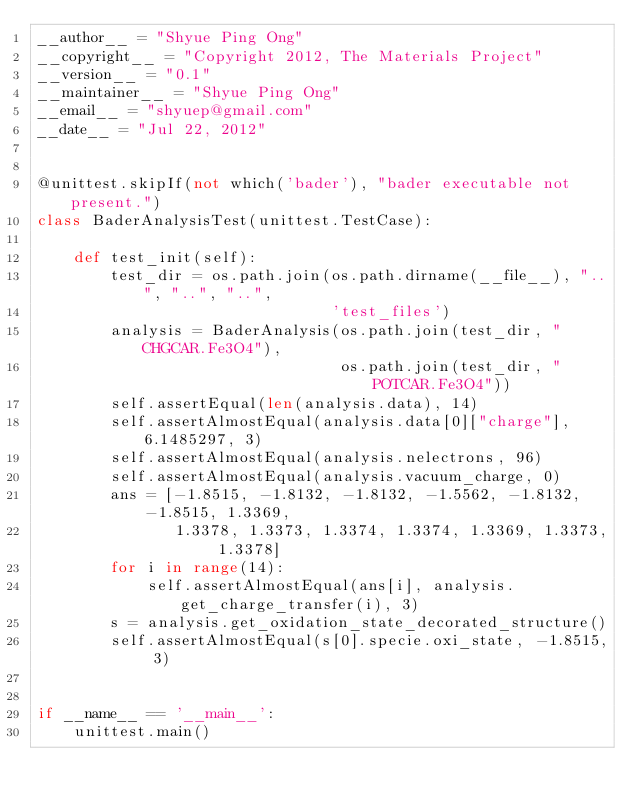Convert code to text. <code><loc_0><loc_0><loc_500><loc_500><_Python_>__author__ = "Shyue Ping Ong"
__copyright__ = "Copyright 2012, The Materials Project"
__version__ = "0.1"
__maintainer__ = "Shyue Ping Ong"
__email__ = "shyuep@gmail.com"
__date__ = "Jul 22, 2012"


@unittest.skipIf(not which('bader'), "bader executable not present.")
class BaderAnalysisTest(unittest.TestCase):

    def test_init(self):
        test_dir = os.path.join(os.path.dirname(__file__), "..", "..", "..",
                                'test_files')
        analysis = BaderAnalysis(os.path.join(test_dir, "CHGCAR.Fe3O4"),
                                 os.path.join(test_dir, "POTCAR.Fe3O4"))
        self.assertEqual(len(analysis.data), 14)
        self.assertAlmostEqual(analysis.data[0]["charge"], 6.1485297, 3)
        self.assertAlmostEqual(analysis.nelectrons, 96)
        self.assertAlmostEqual(analysis.vacuum_charge, 0)
        ans = [-1.8515, -1.8132, -1.8132, -1.5562, -1.8132, -1.8515, 1.3369,
               1.3378, 1.3373, 1.3374, 1.3374, 1.3369, 1.3373, 1.3378]
        for i in range(14):
            self.assertAlmostEqual(ans[i], analysis.get_charge_transfer(i), 3)
        s = analysis.get_oxidation_state_decorated_structure()
        self.assertAlmostEqual(s[0].specie.oxi_state, -1.8515, 3)


if __name__ == '__main__':
    unittest.main()
</code> 